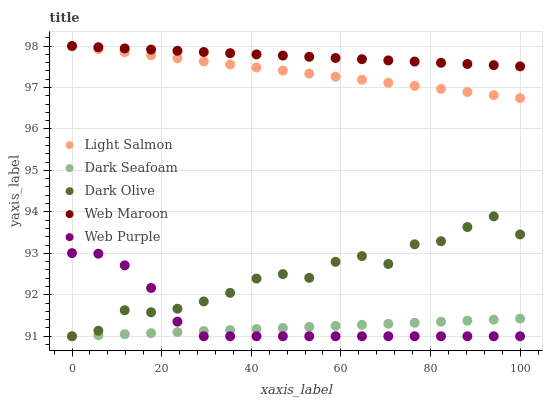Does Dark Seafoam have the minimum area under the curve?
Answer yes or no. Yes. Does Web Maroon have the maximum area under the curve?
Answer yes or no. Yes. Does Light Salmon have the minimum area under the curve?
Answer yes or no. No. Does Light Salmon have the maximum area under the curve?
Answer yes or no. No. Is Web Maroon the smoothest?
Answer yes or no. Yes. Is Dark Olive the roughest?
Answer yes or no. Yes. Is Light Salmon the smoothest?
Answer yes or no. No. Is Light Salmon the roughest?
Answer yes or no. No. Does Web Purple have the lowest value?
Answer yes or no. Yes. Does Light Salmon have the lowest value?
Answer yes or no. No. Does Web Maroon have the highest value?
Answer yes or no. Yes. Does Dark Olive have the highest value?
Answer yes or no. No. Is Dark Seafoam less than Web Maroon?
Answer yes or no. Yes. Is Web Maroon greater than Dark Olive?
Answer yes or no. Yes. Does Web Purple intersect Dark Seafoam?
Answer yes or no. Yes. Is Web Purple less than Dark Seafoam?
Answer yes or no. No. Is Web Purple greater than Dark Seafoam?
Answer yes or no. No. Does Dark Seafoam intersect Web Maroon?
Answer yes or no. No. 